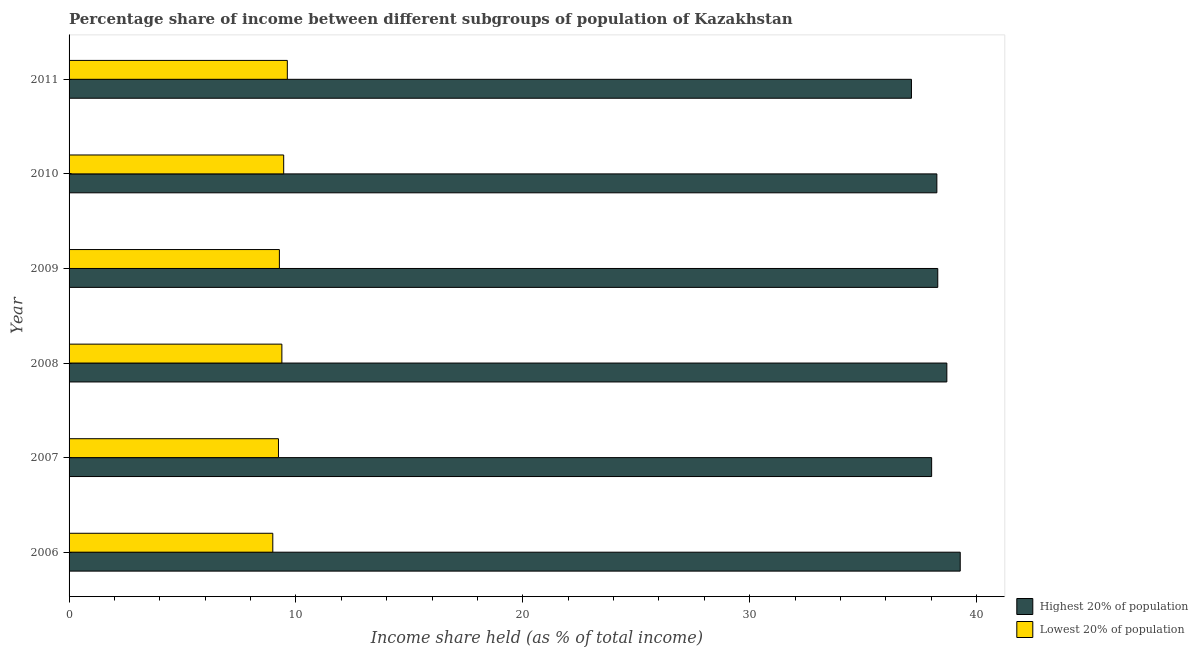Are the number of bars per tick equal to the number of legend labels?
Offer a terse response. Yes. What is the income share held by highest 20% of the population in 2008?
Offer a terse response. 38.69. Across all years, what is the maximum income share held by lowest 20% of the population?
Your answer should be very brief. 9.62. Across all years, what is the minimum income share held by lowest 20% of the population?
Keep it short and to the point. 8.98. In which year was the income share held by lowest 20% of the population maximum?
Keep it short and to the point. 2011. In which year was the income share held by highest 20% of the population minimum?
Offer a terse response. 2011. What is the total income share held by lowest 20% of the population in the graph?
Your response must be concise. 55.94. What is the difference between the income share held by lowest 20% of the population in 2006 and that in 2007?
Your response must be concise. -0.25. What is the difference between the income share held by lowest 20% of the population in 2010 and the income share held by highest 20% of the population in 2006?
Give a very brief answer. -29.82. What is the average income share held by highest 20% of the population per year?
Give a very brief answer. 38.28. In the year 2008, what is the difference between the income share held by lowest 20% of the population and income share held by highest 20% of the population?
Ensure brevity in your answer.  -29.31. What is the ratio of the income share held by highest 20% of the population in 2009 to that in 2011?
Your answer should be compact. 1.03. What is the difference between the highest and the second highest income share held by highest 20% of the population?
Give a very brief answer. 0.59. What is the difference between the highest and the lowest income share held by lowest 20% of the population?
Your answer should be compact. 0.64. Is the sum of the income share held by highest 20% of the population in 2009 and 2011 greater than the maximum income share held by lowest 20% of the population across all years?
Ensure brevity in your answer.  Yes. What does the 1st bar from the top in 2007 represents?
Ensure brevity in your answer.  Lowest 20% of population. What does the 2nd bar from the bottom in 2009 represents?
Make the answer very short. Lowest 20% of population. How many bars are there?
Ensure brevity in your answer.  12. Are all the bars in the graph horizontal?
Provide a short and direct response. Yes. Are the values on the major ticks of X-axis written in scientific E-notation?
Give a very brief answer. No. Does the graph contain grids?
Your answer should be compact. No. How many legend labels are there?
Your answer should be compact. 2. How are the legend labels stacked?
Make the answer very short. Vertical. What is the title of the graph?
Your response must be concise. Percentage share of income between different subgroups of population of Kazakhstan. Does "Female labourers" appear as one of the legend labels in the graph?
Keep it short and to the point. No. What is the label or title of the X-axis?
Give a very brief answer. Income share held (as % of total income). What is the label or title of the Y-axis?
Make the answer very short. Year. What is the Income share held (as % of total income) in Highest 20% of population in 2006?
Offer a terse response. 39.28. What is the Income share held (as % of total income) of Lowest 20% of population in 2006?
Provide a short and direct response. 8.98. What is the Income share held (as % of total income) in Highest 20% of population in 2007?
Your response must be concise. 38.02. What is the Income share held (as % of total income) of Lowest 20% of population in 2007?
Provide a succinct answer. 9.23. What is the Income share held (as % of total income) of Highest 20% of population in 2008?
Your response must be concise. 38.69. What is the Income share held (as % of total income) of Lowest 20% of population in 2008?
Your response must be concise. 9.38. What is the Income share held (as % of total income) of Highest 20% of population in 2009?
Make the answer very short. 38.29. What is the Income share held (as % of total income) of Lowest 20% of population in 2009?
Offer a terse response. 9.27. What is the Income share held (as % of total income) in Highest 20% of population in 2010?
Give a very brief answer. 38.25. What is the Income share held (as % of total income) of Lowest 20% of population in 2010?
Make the answer very short. 9.46. What is the Income share held (as % of total income) in Highest 20% of population in 2011?
Your response must be concise. 37.13. What is the Income share held (as % of total income) in Lowest 20% of population in 2011?
Offer a very short reply. 9.62. Across all years, what is the maximum Income share held (as % of total income) of Highest 20% of population?
Provide a short and direct response. 39.28. Across all years, what is the maximum Income share held (as % of total income) in Lowest 20% of population?
Keep it short and to the point. 9.62. Across all years, what is the minimum Income share held (as % of total income) of Highest 20% of population?
Keep it short and to the point. 37.13. Across all years, what is the minimum Income share held (as % of total income) of Lowest 20% of population?
Provide a succinct answer. 8.98. What is the total Income share held (as % of total income) in Highest 20% of population in the graph?
Ensure brevity in your answer.  229.66. What is the total Income share held (as % of total income) of Lowest 20% of population in the graph?
Provide a short and direct response. 55.94. What is the difference between the Income share held (as % of total income) in Highest 20% of population in 2006 and that in 2007?
Your response must be concise. 1.26. What is the difference between the Income share held (as % of total income) in Lowest 20% of population in 2006 and that in 2007?
Make the answer very short. -0.25. What is the difference between the Income share held (as % of total income) of Highest 20% of population in 2006 and that in 2008?
Offer a very short reply. 0.59. What is the difference between the Income share held (as % of total income) of Lowest 20% of population in 2006 and that in 2008?
Your answer should be very brief. -0.4. What is the difference between the Income share held (as % of total income) of Lowest 20% of population in 2006 and that in 2009?
Give a very brief answer. -0.29. What is the difference between the Income share held (as % of total income) of Highest 20% of population in 2006 and that in 2010?
Offer a very short reply. 1.03. What is the difference between the Income share held (as % of total income) of Lowest 20% of population in 2006 and that in 2010?
Offer a terse response. -0.48. What is the difference between the Income share held (as % of total income) of Highest 20% of population in 2006 and that in 2011?
Ensure brevity in your answer.  2.15. What is the difference between the Income share held (as % of total income) of Lowest 20% of population in 2006 and that in 2011?
Provide a succinct answer. -0.64. What is the difference between the Income share held (as % of total income) in Highest 20% of population in 2007 and that in 2008?
Your answer should be compact. -0.67. What is the difference between the Income share held (as % of total income) in Lowest 20% of population in 2007 and that in 2008?
Your answer should be very brief. -0.15. What is the difference between the Income share held (as % of total income) in Highest 20% of population in 2007 and that in 2009?
Give a very brief answer. -0.27. What is the difference between the Income share held (as % of total income) in Lowest 20% of population in 2007 and that in 2009?
Your response must be concise. -0.04. What is the difference between the Income share held (as % of total income) of Highest 20% of population in 2007 and that in 2010?
Provide a succinct answer. -0.23. What is the difference between the Income share held (as % of total income) of Lowest 20% of population in 2007 and that in 2010?
Your answer should be very brief. -0.23. What is the difference between the Income share held (as % of total income) in Highest 20% of population in 2007 and that in 2011?
Your answer should be compact. 0.89. What is the difference between the Income share held (as % of total income) in Lowest 20% of population in 2007 and that in 2011?
Ensure brevity in your answer.  -0.39. What is the difference between the Income share held (as % of total income) of Highest 20% of population in 2008 and that in 2009?
Offer a very short reply. 0.4. What is the difference between the Income share held (as % of total income) of Lowest 20% of population in 2008 and that in 2009?
Offer a very short reply. 0.11. What is the difference between the Income share held (as % of total income) of Highest 20% of population in 2008 and that in 2010?
Your answer should be very brief. 0.44. What is the difference between the Income share held (as % of total income) in Lowest 20% of population in 2008 and that in 2010?
Provide a short and direct response. -0.08. What is the difference between the Income share held (as % of total income) of Highest 20% of population in 2008 and that in 2011?
Provide a short and direct response. 1.56. What is the difference between the Income share held (as % of total income) in Lowest 20% of population in 2008 and that in 2011?
Ensure brevity in your answer.  -0.24. What is the difference between the Income share held (as % of total income) in Lowest 20% of population in 2009 and that in 2010?
Provide a short and direct response. -0.19. What is the difference between the Income share held (as % of total income) in Highest 20% of population in 2009 and that in 2011?
Make the answer very short. 1.16. What is the difference between the Income share held (as % of total income) of Lowest 20% of population in 2009 and that in 2011?
Offer a very short reply. -0.35. What is the difference between the Income share held (as % of total income) of Highest 20% of population in 2010 and that in 2011?
Offer a terse response. 1.12. What is the difference between the Income share held (as % of total income) of Lowest 20% of population in 2010 and that in 2011?
Offer a very short reply. -0.16. What is the difference between the Income share held (as % of total income) in Highest 20% of population in 2006 and the Income share held (as % of total income) in Lowest 20% of population in 2007?
Give a very brief answer. 30.05. What is the difference between the Income share held (as % of total income) of Highest 20% of population in 2006 and the Income share held (as % of total income) of Lowest 20% of population in 2008?
Your answer should be compact. 29.9. What is the difference between the Income share held (as % of total income) in Highest 20% of population in 2006 and the Income share held (as % of total income) in Lowest 20% of population in 2009?
Keep it short and to the point. 30.01. What is the difference between the Income share held (as % of total income) of Highest 20% of population in 2006 and the Income share held (as % of total income) of Lowest 20% of population in 2010?
Provide a short and direct response. 29.82. What is the difference between the Income share held (as % of total income) in Highest 20% of population in 2006 and the Income share held (as % of total income) in Lowest 20% of population in 2011?
Keep it short and to the point. 29.66. What is the difference between the Income share held (as % of total income) in Highest 20% of population in 2007 and the Income share held (as % of total income) in Lowest 20% of population in 2008?
Give a very brief answer. 28.64. What is the difference between the Income share held (as % of total income) in Highest 20% of population in 2007 and the Income share held (as % of total income) in Lowest 20% of population in 2009?
Provide a succinct answer. 28.75. What is the difference between the Income share held (as % of total income) of Highest 20% of population in 2007 and the Income share held (as % of total income) of Lowest 20% of population in 2010?
Offer a terse response. 28.56. What is the difference between the Income share held (as % of total income) in Highest 20% of population in 2007 and the Income share held (as % of total income) in Lowest 20% of population in 2011?
Offer a very short reply. 28.4. What is the difference between the Income share held (as % of total income) of Highest 20% of population in 2008 and the Income share held (as % of total income) of Lowest 20% of population in 2009?
Your answer should be compact. 29.42. What is the difference between the Income share held (as % of total income) in Highest 20% of population in 2008 and the Income share held (as % of total income) in Lowest 20% of population in 2010?
Your answer should be very brief. 29.23. What is the difference between the Income share held (as % of total income) of Highest 20% of population in 2008 and the Income share held (as % of total income) of Lowest 20% of population in 2011?
Provide a short and direct response. 29.07. What is the difference between the Income share held (as % of total income) of Highest 20% of population in 2009 and the Income share held (as % of total income) of Lowest 20% of population in 2010?
Give a very brief answer. 28.83. What is the difference between the Income share held (as % of total income) in Highest 20% of population in 2009 and the Income share held (as % of total income) in Lowest 20% of population in 2011?
Ensure brevity in your answer.  28.67. What is the difference between the Income share held (as % of total income) in Highest 20% of population in 2010 and the Income share held (as % of total income) in Lowest 20% of population in 2011?
Offer a very short reply. 28.63. What is the average Income share held (as % of total income) in Highest 20% of population per year?
Offer a terse response. 38.28. What is the average Income share held (as % of total income) in Lowest 20% of population per year?
Your answer should be compact. 9.32. In the year 2006, what is the difference between the Income share held (as % of total income) in Highest 20% of population and Income share held (as % of total income) in Lowest 20% of population?
Provide a succinct answer. 30.3. In the year 2007, what is the difference between the Income share held (as % of total income) in Highest 20% of population and Income share held (as % of total income) in Lowest 20% of population?
Offer a very short reply. 28.79. In the year 2008, what is the difference between the Income share held (as % of total income) of Highest 20% of population and Income share held (as % of total income) of Lowest 20% of population?
Offer a very short reply. 29.31. In the year 2009, what is the difference between the Income share held (as % of total income) in Highest 20% of population and Income share held (as % of total income) in Lowest 20% of population?
Give a very brief answer. 29.02. In the year 2010, what is the difference between the Income share held (as % of total income) in Highest 20% of population and Income share held (as % of total income) in Lowest 20% of population?
Make the answer very short. 28.79. In the year 2011, what is the difference between the Income share held (as % of total income) of Highest 20% of population and Income share held (as % of total income) of Lowest 20% of population?
Your answer should be compact. 27.51. What is the ratio of the Income share held (as % of total income) in Highest 20% of population in 2006 to that in 2007?
Keep it short and to the point. 1.03. What is the ratio of the Income share held (as % of total income) in Lowest 20% of population in 2006 to that in 2007?
Keep it short and to the point. 0.97. What is the ratio of the Income share held (as % of total income) in Highest 20% of population in 2006 to that in 2008?
Make the answer very short. 1.02. What is the ratio of the Income share held (as % of total income) of Lowest 20% of population in 2006 to that in 2008?
Your answer should be very brief. 0.96. What is the ratio of the Income share held (as % of total income) in Highest 20% of population in 2006 to that in 2009?
Offer a terse response. 1.03. What is the ratio of the Income share held (as % of total income) of Lowest 20% of population in 2006 to that in 2009?
Offer a terse response. 0.97. What is the ratio of the Income share held (as % of total income) of Highest 20% of population in 2006 to that in 2010?
Give a very brief answer. 1.03. What is the ratio of the Income share held (as % of total income) in Lowest 20% of population in 2006 to that in 2010?
Provide a succinct answer. 0.95. What is the ratio of the Income share held (as % of total income) in Highest 20% of population in 2006 to that in 2011?
Your response must be concise. 1.06. What is the ratio of the Income share held (as % of total income) in Lowest 20% of population in 2006 to that in 2011?
Your answer should be very brief. 0.93. What is the ratio of the Income share held (as % of total income) in Highest 20% of population in 2007 to that in 2008?
Your answer should be very brief. 0.98. What is the ratio of the Income share held (as % of total income) in Highest 20% of population in 2007 to that in 2009?
Ensure brevity in your answer.  0.99. What is the ratio of the Income share held (as % of total income) in Lowest 20% of population in 2007 to that in 2009?
Your response must be concise. 1. What is the ratio of the Income share held (as % of total income) of Highest 20% of population in 2007 to that in 2010?
Offer a very short reply. 0.99. What is the ratio of the Income share held (as % of total income) of Lowest 20% of population in 2007 to that in 2010?
Give a very brief answer. 0.98. What is the ratio of the Income share held (as % of total income) in Lowest 20% of population in 2007 to that in 2011?
Offer a terse response. 0.96. What is the ratio of the Income share held (as % of total income) in Highest 20% of population in 2008 to that in 2009?
Provide a short and direct response. 1.01. What is the ratio of the Income share held (as % of total income) in Lowest 20% of population in 2008 to that in 2009?
Provide a short and direct response. 1.01. What is the ratio of the Income share held (as % of total income) in Highest 20% of population in 2008 to that in 2010?
Your response must be concise. 1.01. What is the ratio of the Income share held (as % of total income) of Lowest 20% of population in 2008 to that in 2010?
Provide a succinct answer. 0.99. What is the ratio of the Income share held (as % of total income) in Highest 20% of population in 2008 to that in 2011?
Offer a terse response. 1.04. What is the ratio of the Income share held (as % of total income) in Lowest 20% of population in 2008 to that in 2011?
Ensure brevity in your answer.  0.98. What is the ratio of the Income share held (as % of total income) in Highest 20% of population in 2009 to that in 2010?
Provide a succinct answer. 1. What is the ratio of the Income share held (as % of total income) of Lowest 20% of population in 2009 to that in 2010?
Give a very brief answer. 0.98. What is the ratio of the Income share held (as % of total income) in Highest 20% of population in 2009 to that in 2011?
Ensure brevity in your answer.  1.03. What is the ratio of the Income share held (as % of total income) of Lowest 20% of population in 2009 to that in 2011?
Offer a very short reply. 0.96. What is the ratio of the Income share held (as % of total income) in Highest 20% of population in 2010 to that in 2011?
Your answer should be compact. 1.03. What is the ratio of the Income share held (as % of total income) in Lowest 20% of population in 2010 to that in 2011?
Your answer should be compact. 0.98. What is the difference between the highest and the second highest Income share held (as % of total income) of Highest 20% of population?
Your answer should be very brief. 0.59. What is the difference between the highest and the second highest Income share held (as % of total income) in Lowest 20% of population?
Provide a short and direct response. 0.16. What is the difference between the highest and the lowest Income share held (as % of total income) of Highest 20% of population?
Give a very brief answer. 2.15. What is the difference between the highest and the lowest Income share held (as % of total income) of Lowest 20% of population?
Your response must be concise. 0.64. 